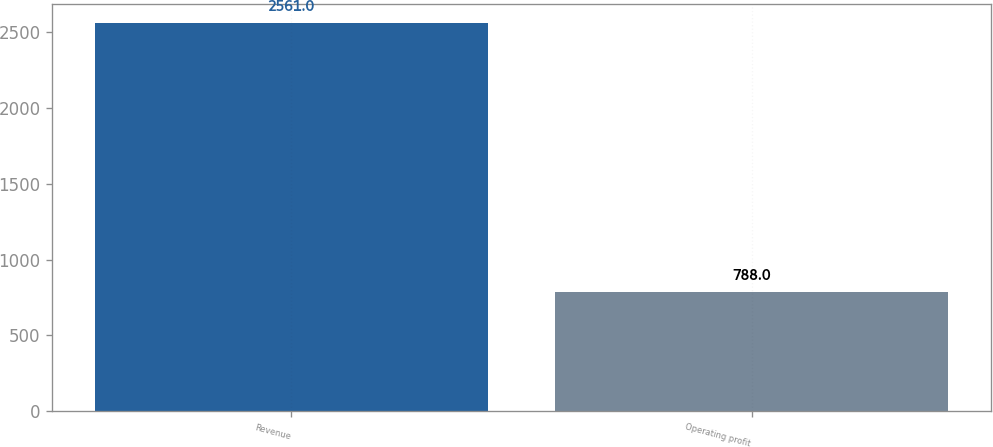Convert chart. <chart><loc_0><loc_0><loc_500><loc_500><bar_chart><fcel>Revenue<fcel>Operating profit<nl><fcel>2561<fcel>788<nl></chart> 